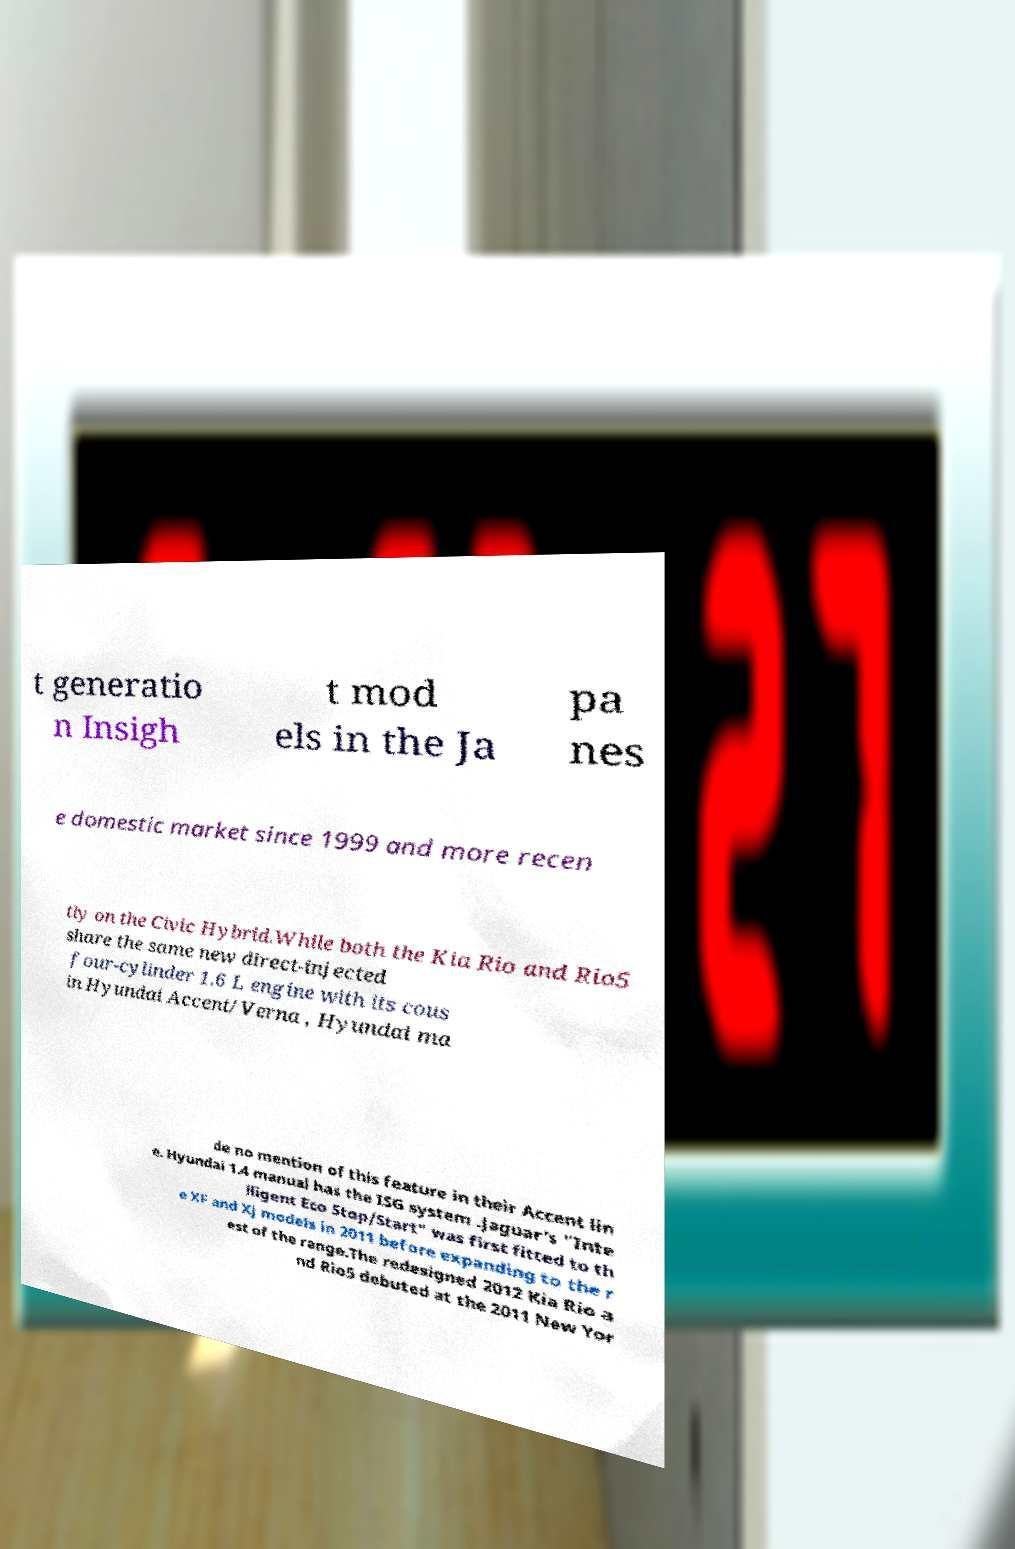There's text embedded in this image that I need extracted. Can you transcribe it verbatim? t generatio n Insigh t mod els in the Ja pa nes e domestic market since 1999 and more recen tly on the Civic Hybrid.While both the Kia Rio and Rio5 share the same new direct-injected four-cylinder 1.6 L engine with its cous in Hyundai Accent/Verna , Hyundai ma de no mention of this feature in their Accent lin e. Hyundai 1.4 manual has the ISG system .Jaguar's "Inte lligent Eco Stop/Start" was first fitted to th e XF and XJ models in 2011 before expanding to the r est of the range.The redesigned 2012 Kia Rio a nd Rio5 debuted at the 2011 New Yor 